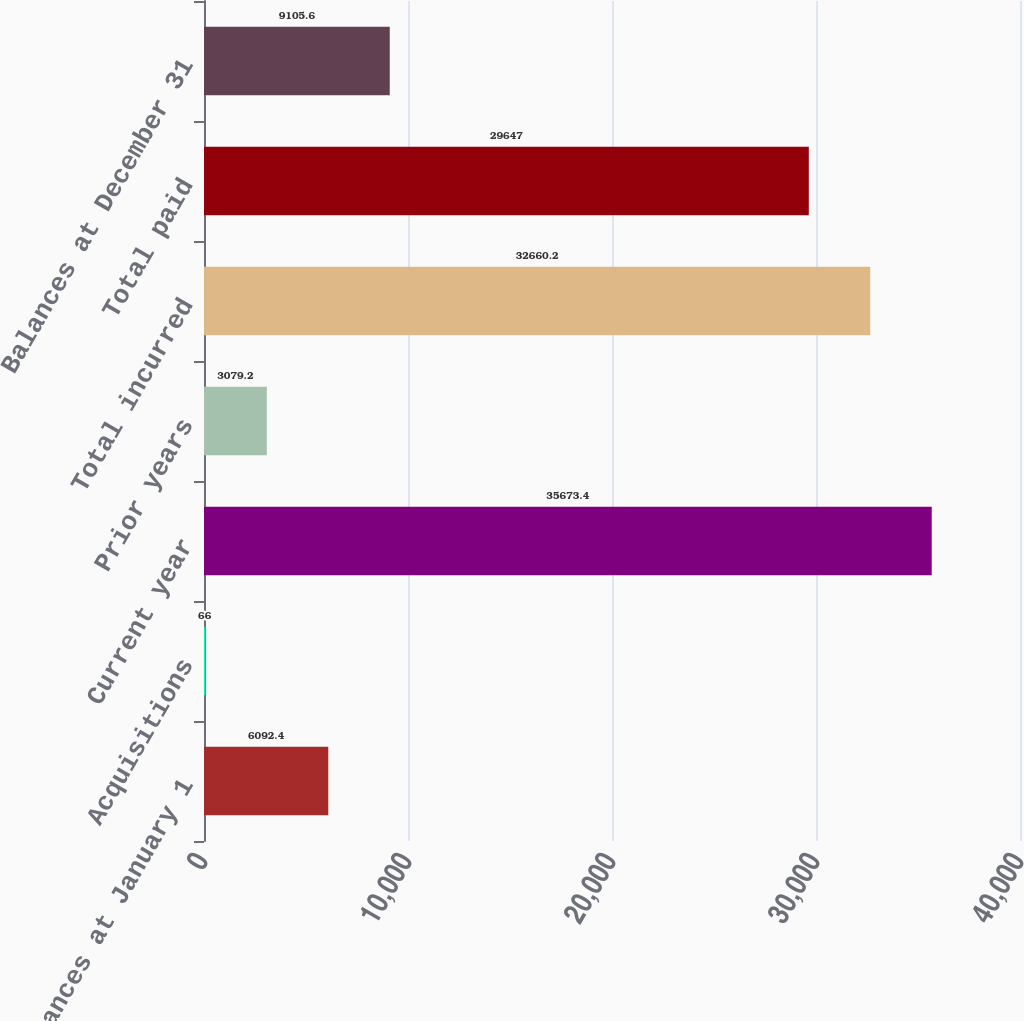Convert chart. <chart><loc_0><loc_0><loc_500><loc_500><bar_chart><fcel>Balances at January 1<fcel>Acquisitions<fcel>Current year<fcel>Prior years<fcel>Total incurred<fcel>Total paid<fcel>Balances at December 31<nl><fcel>6092.4<fcel>66<fcel>35673.4<fcel>3079.2<fcel>32660.2<fcel>29647<fcel>9105.6<nl></chart> 